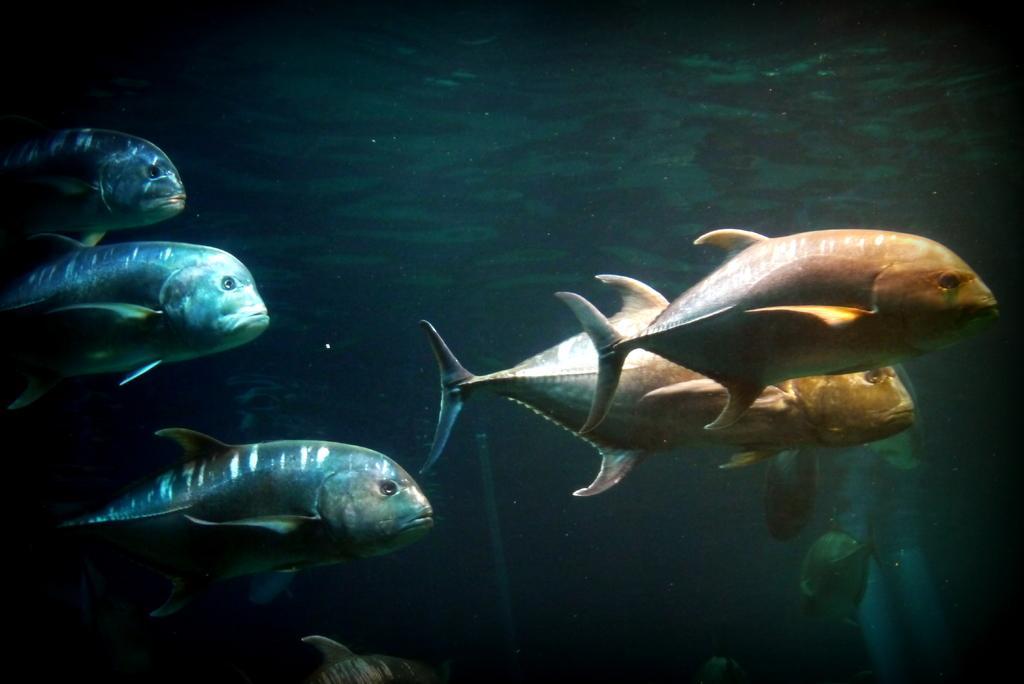In one or two sentences, can you explain what this image depicts? In the picture there is water, there are many fishes present in the water. 